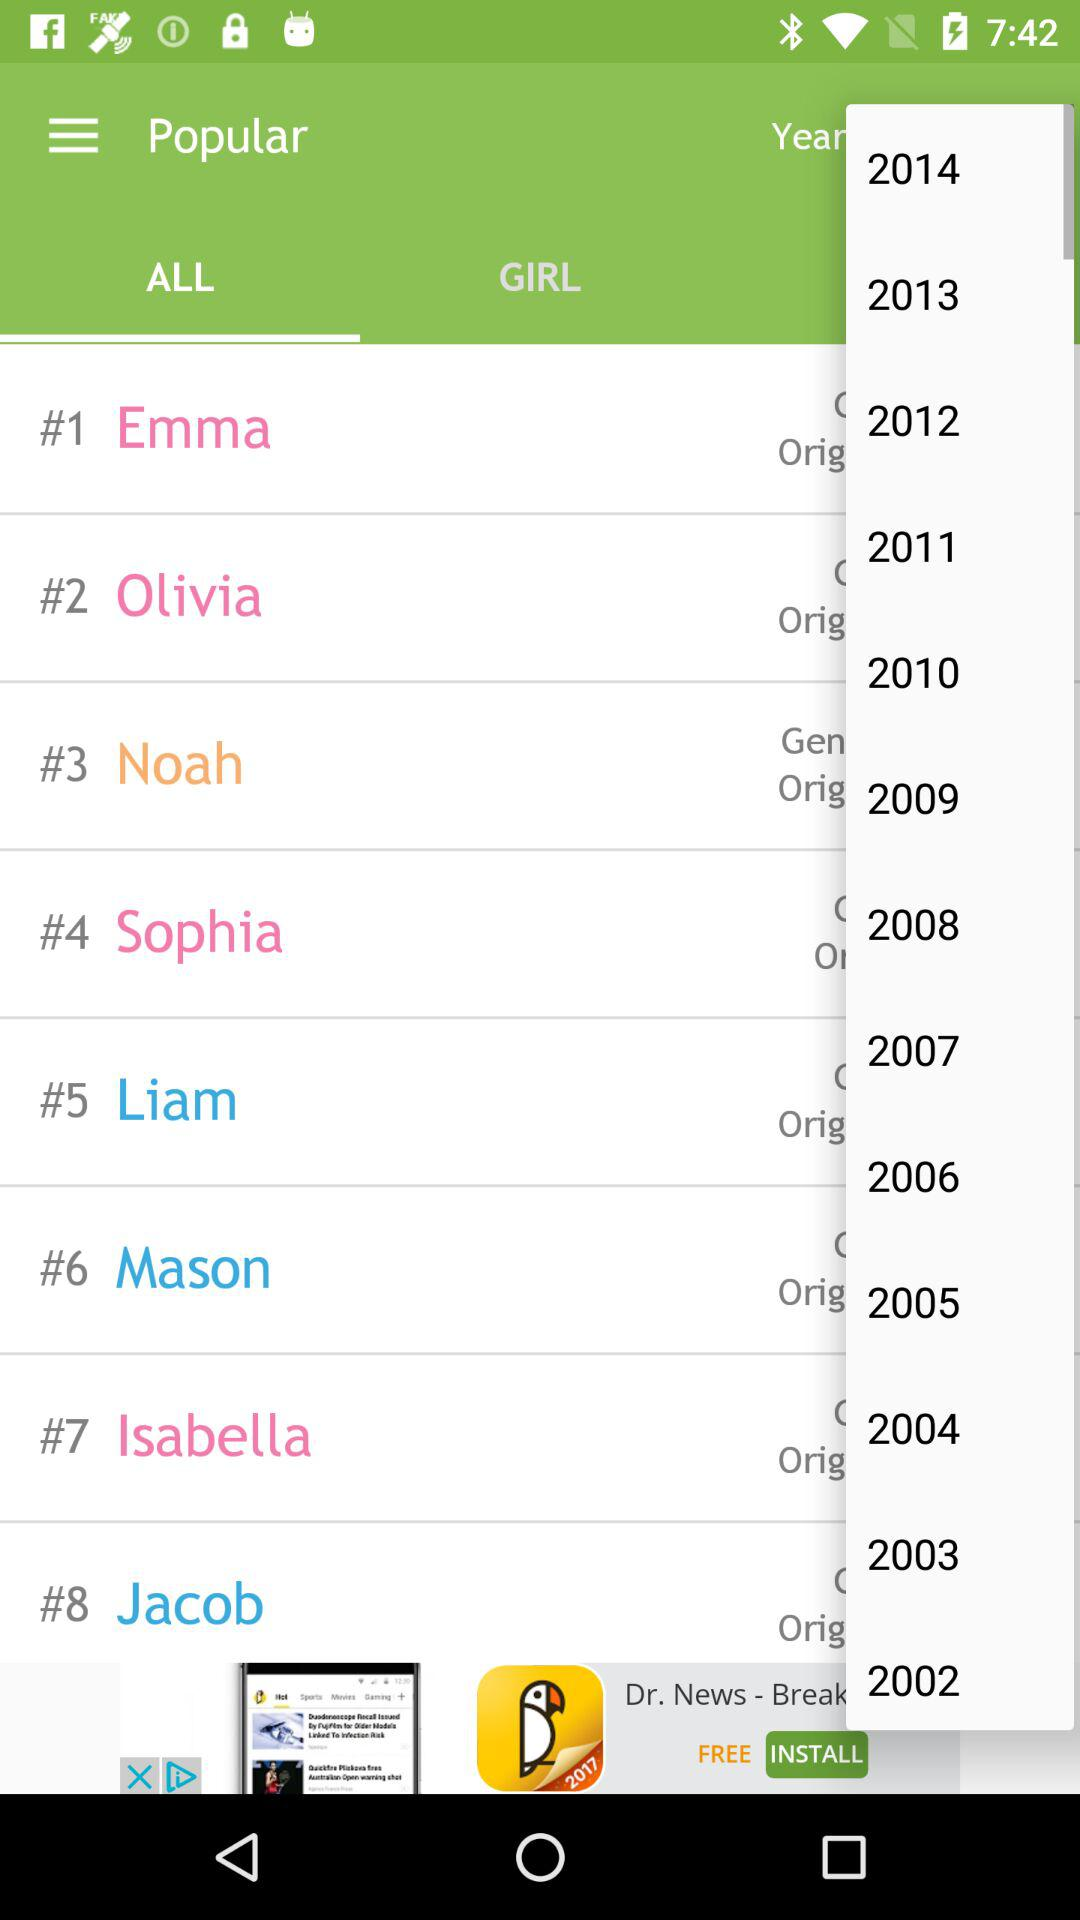Which year is selected?
When the provided information is insufficient, respond with <no answer>. <no answer> 